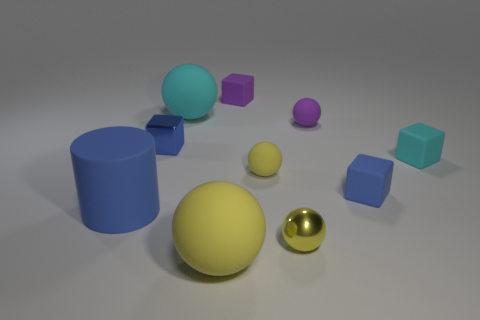What size is the metallic object that is the same shape as the big yellow rubber object?
Offer a very short reply. Small. How many things are small purple matte things right of the yellow metal sphere or tiny objects in front of the tiny cyan block?
Your answer should be very brief. 4. The blue matte object to the right of the large matte sphere that is on the right side of the large cyan matte object is what shape?
Provide a succinct answer. Cube. Are there any other things of the same color as the large matte cylinder?
Your answer should be very brief. Yes. Are there any other things that have the same size as the yellow metal object?
Ensure brevity in your answer.  Yes. What number of objects are tiny cyan things or tiny rubber blocks?
Offer a very short reply. 3. Are there any matte objects that have the same size as the blue shiny object?
Ensure brevity in your answer.  Yes. What is the shape of the large cyan object?
Give a very brief answer. Sphere. Is the number of big cyan matte things left of the blue rubber cylinder greater than the number of small blue metallic things that are in front of the metallic sphere?
Your response must be concise. No. There is a large matte object that is behind the cyan rubber block; is it the same color as the block to the left of the large yellow rubber thing?
Your answer should be very brief. No. 